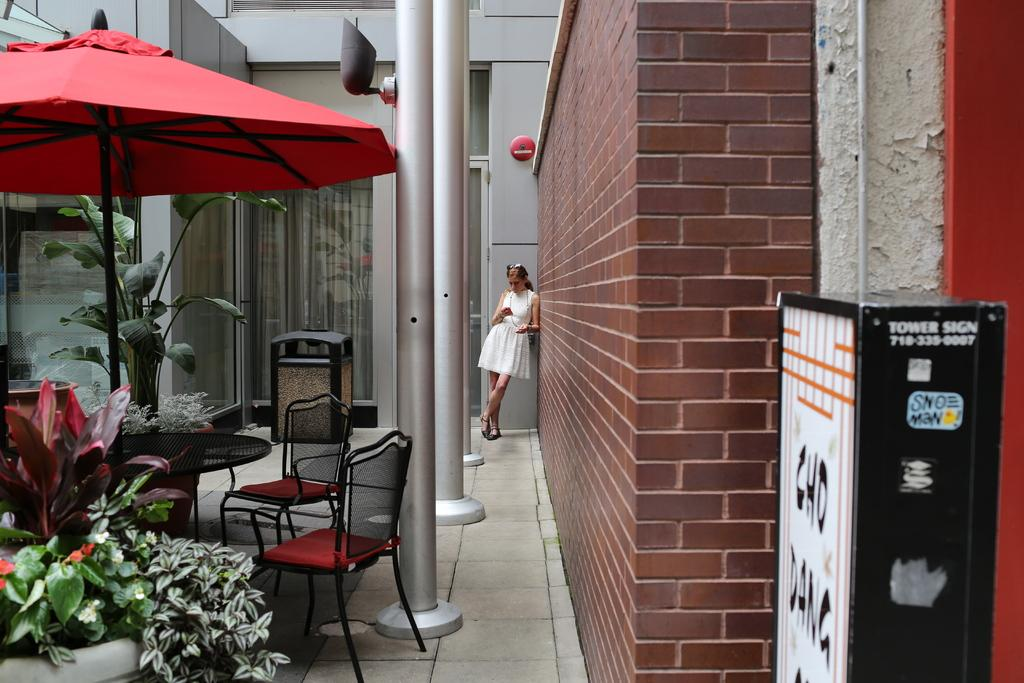What type of furniture is present in the image? There are chairs in the image. What object is used for protection from the sun or rain in the image? There is an umbrella in the image. Who is present in the image? A woman is standing in the image. What type of vegetation can be seen in the image? There are plants visible in the image. What type of payment is being made in the image? There is no payment being made in the image. Is there an argument taking place between the woman and someone else in the image? There is no argument visible in the image. 